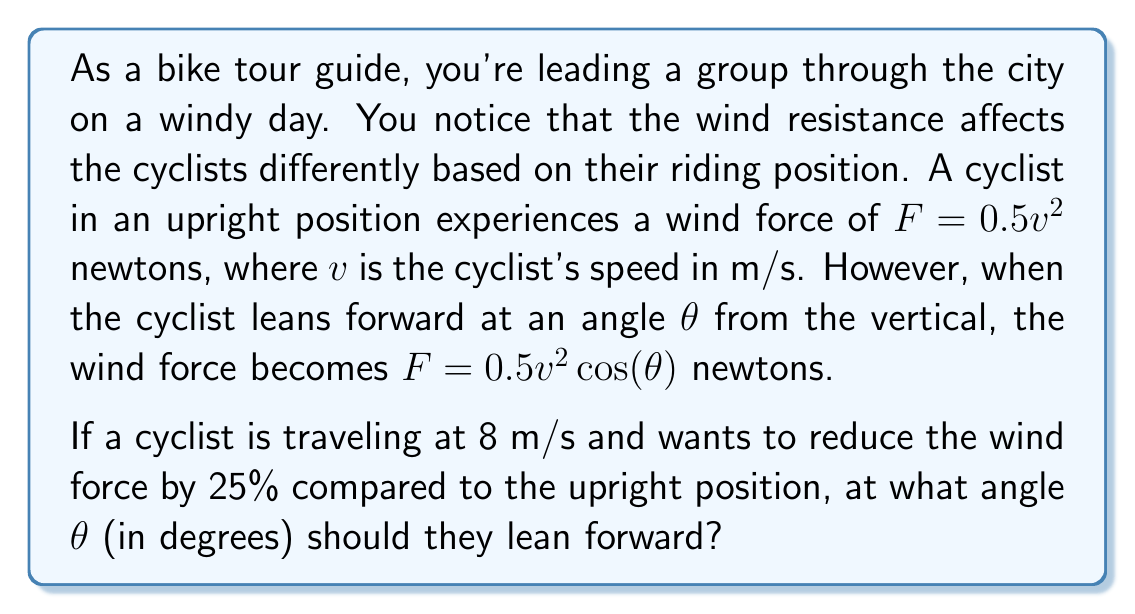What is the answer to this math problem? Let's approach this step-by-step:

1) First, let's calculate the wind force in the upright position:
   $F_{\text{upright}} = 0.5v^2 = 0.5(8^2) = 0.5(64) = 32$ newtons

2) We want to reduce this force by 25%, so the new force should be:
   $F_{\text{leaning}} = 32 \cdot 0.75 = 24$ newtons

3) Now, we can set up our equation using the formula for the leaning position:
   $24 = 0.5(8^2) \cos(\theta)$

4) Simplify:
   $24 = 32 \cos(\theta)$

5) Divide both sides by 32:
   $\frac{24}{32} = \cos(\theta)$
   $0.75 = \cos(\theta)$

6) To solve for $\theta$, we need to take the inverse cosine (arccos) of both sides:
   $\theta = \arccos(0.75)$

7) Using a calculator or trigonometric tables, we can find:
   $\theta \approx 41.4096°$

Therefore, the cyclist should lean forward at an angle of approximately 41.41° from the vertical.
Answer: $\theta \approx 41.41°$ 